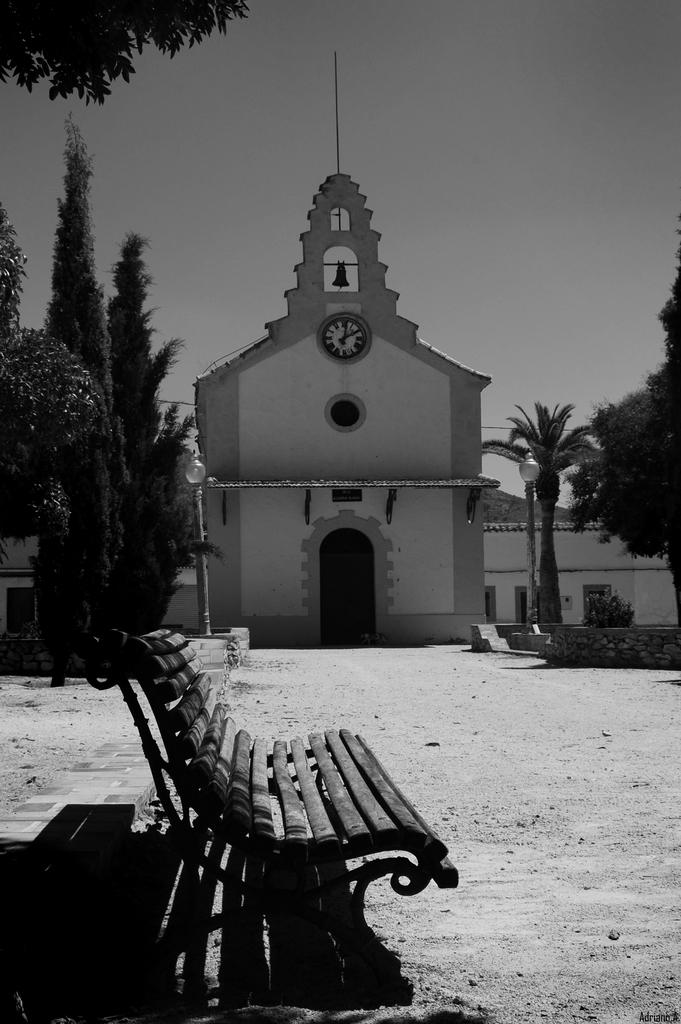What type of seating is visible in the image? There is a bench in the image. What can be seen in the background of the image? There are trees, poles, lights, and buildings in the background of the image. What is the color scheme of the image? The image is in black and white. What is the rate of the pump in the image? There is no pump present in the image, so it is not possible to determine its rate. 